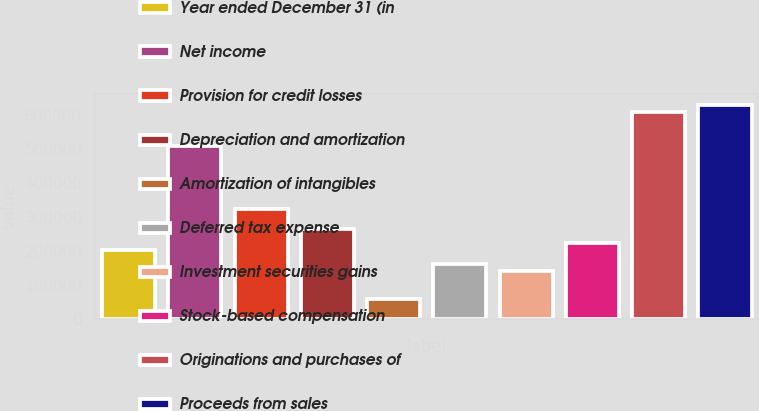Convert chart. <chart><loc_0><loc_0><loc_500><loc_500><bar_chart><fcel>Year ended December 31 (in<fcel>Net income<fcel>Provision for credit losses<fcel>Depreciation and amortization<fcel>Amortization of intangibles<fcel>Deferred tax expense<fcel>Investment securities gains<fcel>Stock-based compensation<fcel>Originations and purchases of<fcel>Proceeds from sales<nl><fcel>203420<fcel>508541<fcel>325468<fcel>264444<fcel>61030.2<fcel>162737<fcel>142396<fcel>223761<fcel>610248<fcel>630589<nl></chart> 